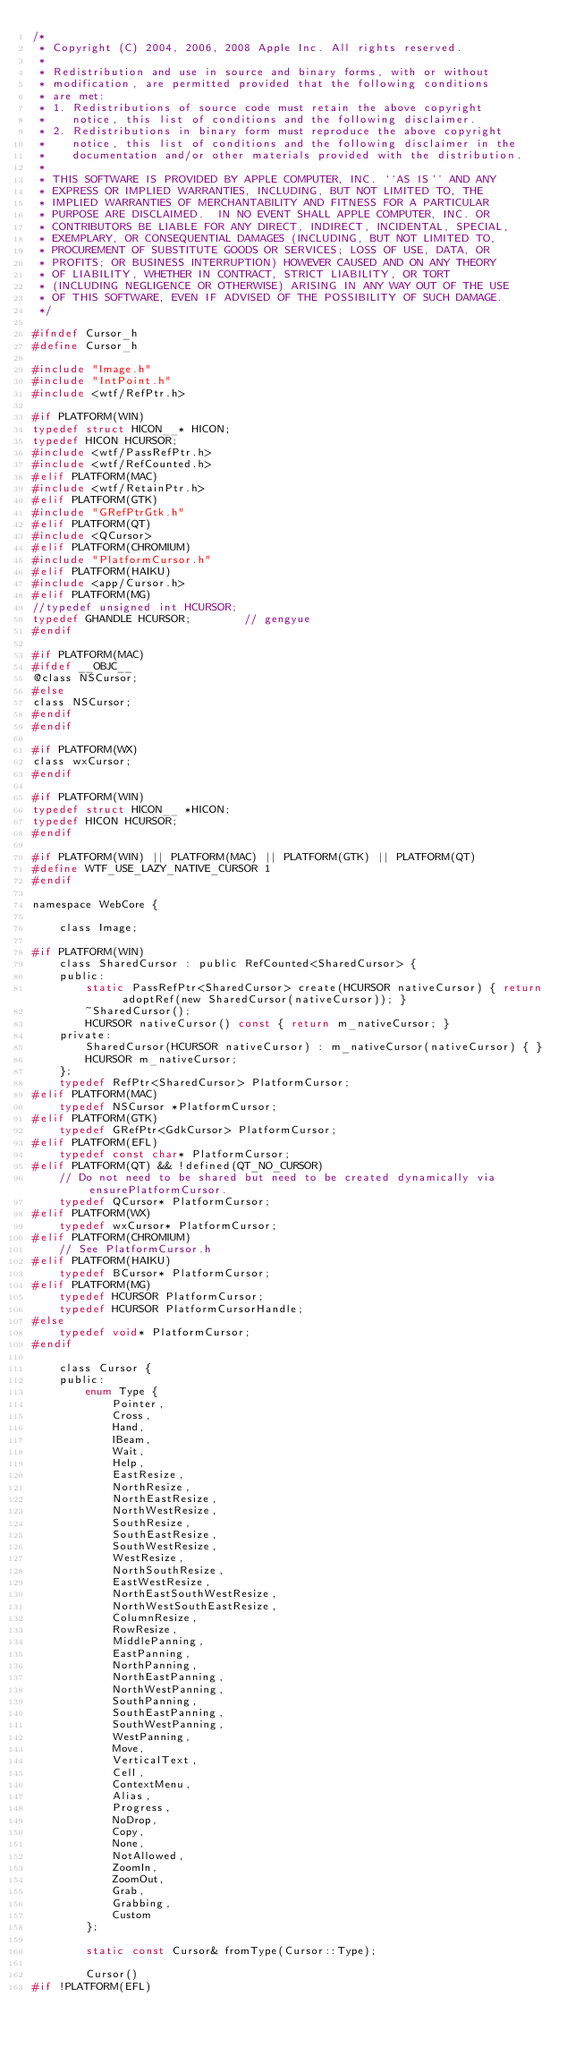<code> <loc_0><loc_0><loc_500><loc_500><_C_>/*
 * Copyright (C) 2004, 2006, 2008 Apple Inc. All rights reserved.
 *
 * Redistribution and use in source and binary forms, with or without
 * modification, are permitted provided that the following conditions
 * are met:
 * 1. Redistributions of source code must retain the above copyright
 *    notice, this list of conditions and the following disclaimer.
 * 2. Redistributions in binary form must reproduce the above copyright
 *    notice, this list of conditions and the following disclaimer in the
 *    documentation and/or other materials provided with the distribution.
 *
 * THIS SOFTWARE IS PROVIDED BY APPLE COMPUTER, INC. ``AS IS'' AND ANY
 * EXPRESS OR IMPLIED WARRANTIES, INCLUDING, BUT NOT LIMITED TO, THE
 * IMPLIED WARRANTIES OF MERCHANTABILITY AND FITNESS FOR A PARTICULAR
 * PURPOSE ARE DISCLAIMED.  IN NO EVENT SHALL APPLE COMPUTER, INC. OR
 * CONTRIBUTORS BE LIABLE FOR ANY DIRECT, INDIRECT, INCIDENTAL, SPECIAL,
 * EXEMPLARY, OR CONSEQUENTIAL DAMAGES (INCLUDING, BUT NOT LIMITED TO,
 * PROCUREMENT OF SUBSTITUTE GOODS OR SERVICES; LOSS OF USE, DATA, OR
 * PROFITS; OR BUSINESS INTERRUPTION) HOWEVER CAUSED AND ON ANY THEORY
 * OF LIABILITY, WHETHER IN CONTRACT, STRICT LIABILITY, OR TORT
 * (INCLUDING NEGLIGENCE OR OTHERWISE) ARISING IN ANY WAY OUT OF THE USE
 * OF THIS SOFTWARE, EVEN IF ADVISED OF THE POSSIBILITY OF SUCH DAMAGE. 
 */

#ifndef Cursor_h
#define Cursor_h

#include "Image.h"
#include "IntPoint.h"
#include <wtf/RefPtr.h>

#if PLATFORM(WIN)
typedef struct HICON__* HICON;
typedef HICON HCURSOR;
#include <wtf/PassRefPtr.h>
#include <wtf/RefCounted.h>
#elif PLATFORM(MAC)
#include <wtf/RetainPtr.h>
#elif PLATFORM(GTK)
#include "GRefPtrGtk.h"
#elif PLATFORM(QT)
#include <QCursor>
#elif PLATFORM(CHROMIUM)
#include "PlatformCursor.h"
#elif PLATFORM(HAIKU)
#include <app/Cursor.h>
#elif PLATFORM(MG)
//typedef unsigned int HCURSOR;
typedef GHANDLE HCURSOR;        // gengyue
#endif

#if PLATFORM(MAC)
#ifdef __OBJC__
@class NSCursor;
#else
class NSCursor;
#endif
#endif

#if PLATFORM(WX)
class wxCursor;
#endif

#if PLATFORM(WIN)
typedef struct HICON__ *HICON;
typedef HICON HCURSOR;
#endif

#if PLATFORM(WIN) || PLATFORM(MAC) || PLATFORM(GTK) || PLATFORM(QT)
#define WTF_USE_LAZY_NATIVE_CURSOR 1
#endif

namespace WebCore {

    class Image;

#if PLATFORM(WIN)
    class SharedCursor : public RefCounted<SharedCursor> {
    public:
        static PassRefPtr<SharedCursor> create(HCURSOR nativeCursor) { return adoptRef(new SharedCursor(nativeCursor)); }
        ~SharedCursor();
        HCURSOR nativeCursor() const { return m_nativeCursor; }
    private:
        SharedCursor(HCURSOR nativeCursor) : m_nativeCursor(nativeCursor) { }
        HCURSOR m_nativeCursor;
    };
    typedef RefPtr<SharedCursor> PlatformCursor;
#elif PLATFORM(MAC)
    typedef NSCursor *PlatformCursor;
#elif PLATFORM(GTK)
    typedef GRefPtr<GdkCursor> PlatformCursor;
#elif PLATFORM(EFL)
    typedef const char* PlatformCursor;
#elif PLATFORM(QT) && !defined(QT_NO_CURSOR)
    // Do not need to be shared but need to be created dynamically via ensurePlatformCursor.
    typedef QCursor* PlatformCursor;
#elif PLATFORM(WX)
    typedef wxCursor* PlatformCursor;
#elif PLATFORM(CHROMIUM)
    // See PlatformCursor.h
#elif PLATFORM(HAIKU)
    typedef BCursor* PlatformCursor;
#elif PLATFORM(MG)
    typedef HCURSOR PlatformCursor;
    typedef HCURSOR PlatformCursorHandle;
#else
    typedef void* PlatformCursor;
#endif

    class Cursor {
    public:
        enum Type {
            Pointer,
            Cross,
            Hand,
            IBeam,
            Wait,
            Help,
            EastResize,
            NorthResize,
            NorthEastResize,
            NorthWestResize,
            SouthResize,
            SouthEastResize,
            SouthWestResize,
            WestResize,
            NorthSouthResize,
            EastWestResize,
            NorthEastSouthWestResize,
            NorthWestSouthEastResize,
            ColumnResize,
            RowResize,
            MiddlePanning,
            EastPanning,
            NorthPanning,
            NorthEastPanning,
            NorthWestPanning,
            SouthPanning,
            SouthEastPanning,
            SouthWestPanning,
            WestPanning,
            Move,
            VerticalText,
            Cell,
            ContextMenu,
            Alias,
            Progress,
            NoDrop,
            Copy,
            None,
            NotAllowed,
            ZoomIn,
            ZoomOut,
            Grab,
            Grabbing,
            Custom
        };

        static const Cursor& fromType(Cursor::Type);

        Cursor()
#if !PLATFORM(EFL)</code> 